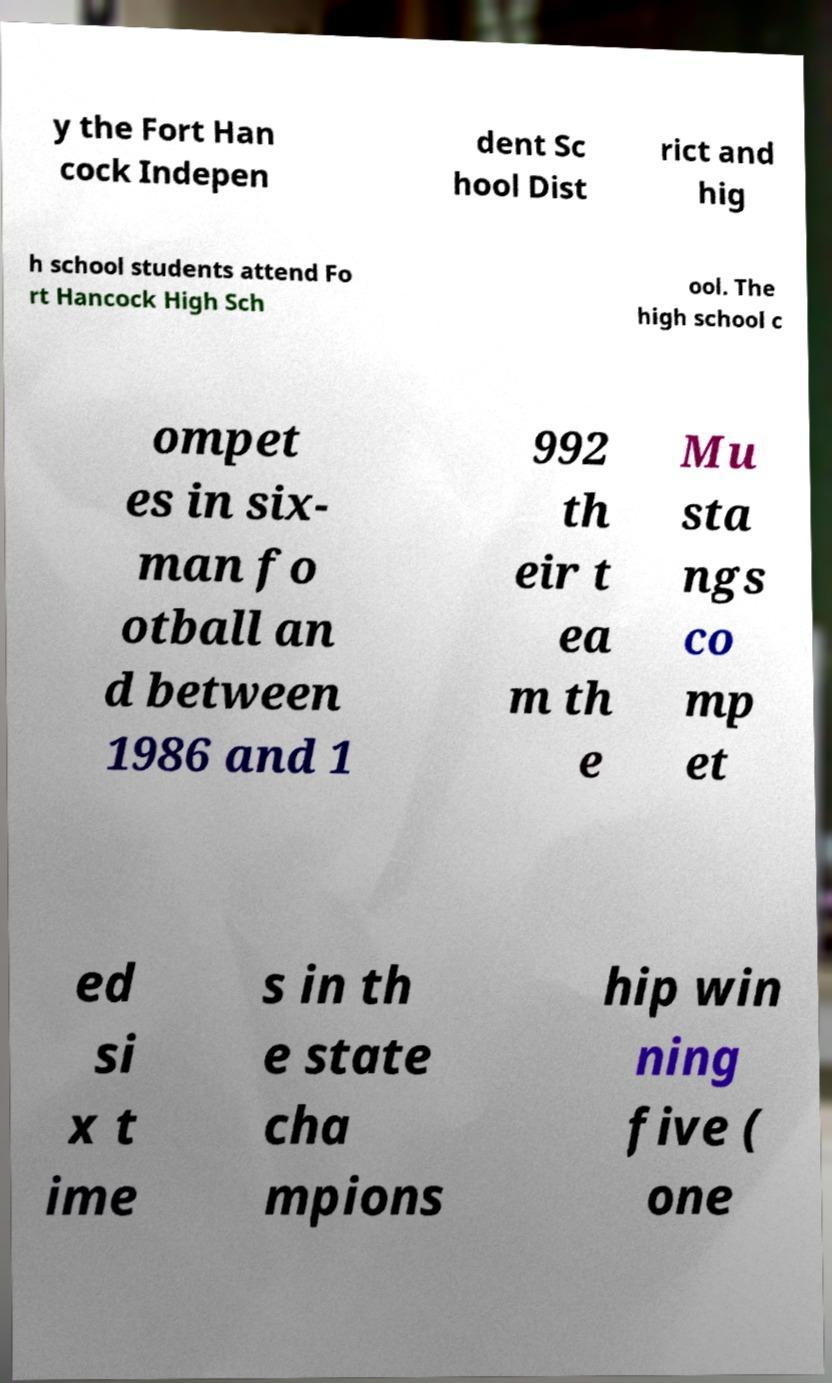What messages or text are displayed in this image? I need them in a readable, typed format. y the Fort Han cock Indepen dent Sc hool Dist rict and hig h school students attend Fo rt Hancock High Sch ool. The high school c ompet es in six- man fo otball an d between 1986 and 1 992 th eir t ea m th e Mu sta ngs co mp et ed si x t ime s in th e state cha mpions hip win ning five ( one 